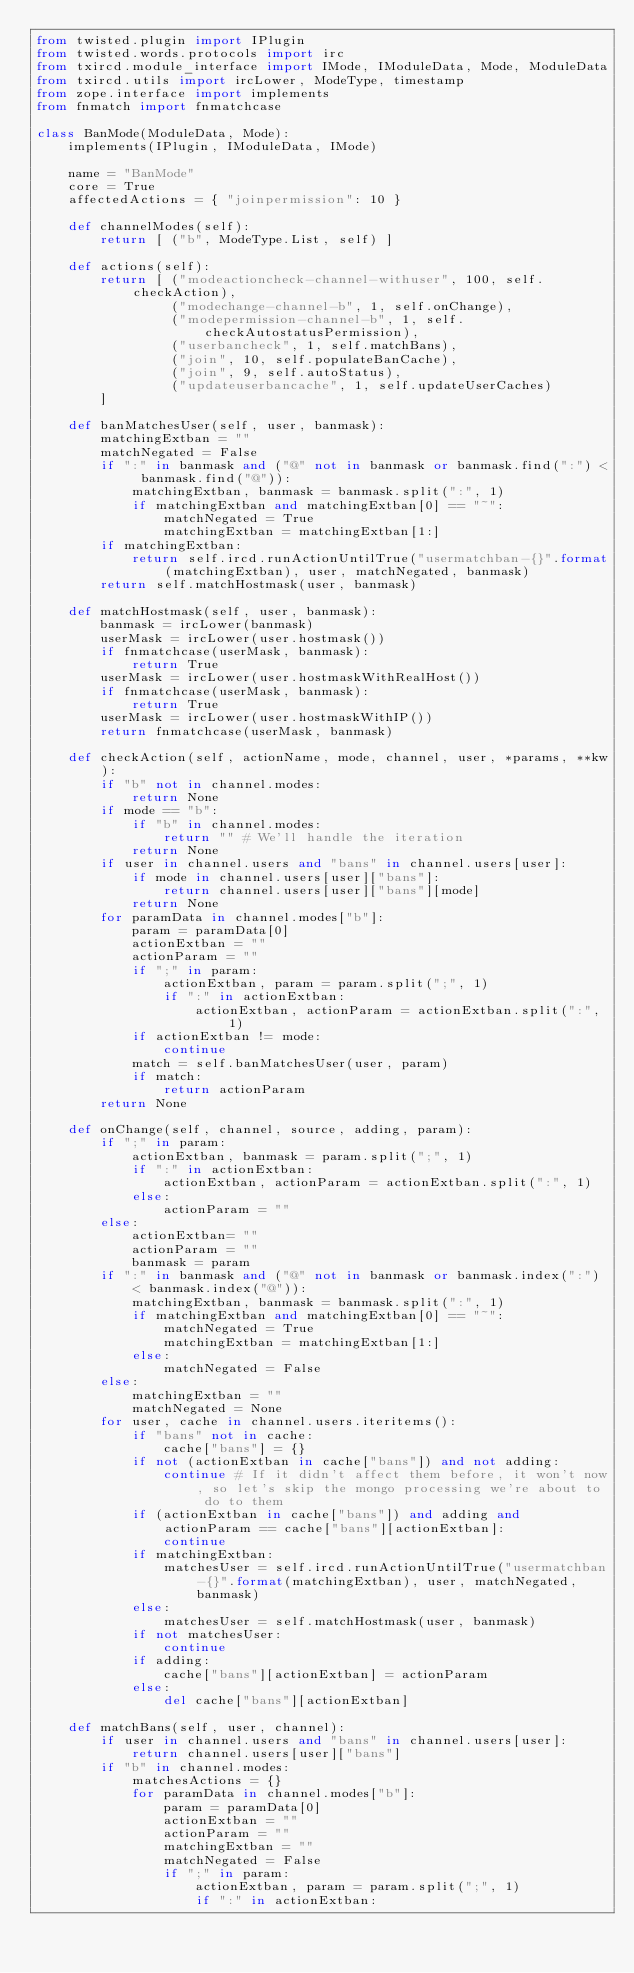Convert code to text. <code><loc_0><loc_0><loc_500><loc_500><_Python_>from twisted.plugin import IPlugin
from twisted.words.protocols import irc
from txircd.module_interface import IMode, IModuleData, Mode, ModuleData
from txircd.utils import ircLower, ModeType, timestamp
from zope.interface import implements
from fnmatch import fnmatchcase

class BanMode(ModuleData, Mode):
	implements(IPlugin, IModuleData, IMode)
	
	name = "BanMode"
	core = True
	affectedActions = { "joinpermission": 10 }
	
	def channelModes(self):
		return [ ("b", ModeType.List, self) ]
	
	def actions(self):
		return [ ("modeactioncheck-channel-withuser", 100, self.checkAction),
		         ("modechange-channel-b", 1, self.onChange),
		         ("modepermission-channel-b", 1, self.checkAutostatusPermission),
		         ("userbancheck", 1, self.matchBans),
		         ("join", 10, self.populateBanCache),
		         ("join", 9, self.autoStatus),
		         ("updateuserbancache", 1, self.updateUserCaches)
		]
	
	def banMatchesUser(self, user, banmask):
		matchingExtban = ""
		matchNegated = False
		if ":" in banmask and ("@" not in banmask or banmask.find(":") < banmask.find("@")):
			matchingExtban, banmask = banmask.split(":", 1)
			if matchingExtban and matchingExtban[0] == "~":
				matchNegated = True
				matchingExtban = matchingExtban[1:]
		if matchingExtban:
			return self.ircd.runActionUntilTrue("usermatchban-{}".format(matchingExtban), user, matchNegated, banmask)
		return self.matchHostmask(user, banmask)
	
	def matchHostmask(self, user, banmask):
		banmask = ircLower(banmask)
		userMask = ircLower(user.hostmask())
		if fnmatchcase(userMask, banmask):
			return True
		userMask = ircLower(user.hostmaskWithRealHost())
		if fnmatchcase(userMask, banmask):
			return True
		userMask = ircLower(user.hostmaskWithIP())
		return fnmatchcase(userMask, banmask)
	
	def checkAction(self, actionName, mode, channel, user, *params, **kw):
		if "b" not in channel.modes:
			return None
		if mode == "b":
			if "b" in channel.modes:
				return "" # We'll handle the iteration
			return None
		if user in channel.users and "bans" in channel.users[user]:
			if mode in channel.users[user]["bans"]:
				return channel.users[user]["bans"][mode]
			return None
		for paramData in channel.modes["b"]:
			param = paramData[0]
			actionExtban = ""
			actionParam = ""
			if ";" in param:
				actionExtban, param = param.split(";", 1)
				if ":" in actionExtban:
					actionExtban, actionParam = actionExtban.split(":", 1)
			if actionExtban != mode:
				continue
			match = self.banMatchesUser(user, param)
			if match:
				return actionParam
		return None
	
	def onChange(self, channel, source, adding, param):
		if ";" in param:
			actionExtban, banmask = param.split(";", 1)
			if ":" in actionExtban:
				actionExtban, actionParam = actionExtban.split(":", 1)
			else:
				actionParam = ""
		else:
			actionExtban= ""
			actionParam = ""
			banmask = param
		if ":" in banmask and ("@" not in banmask or banmask.index(":") < banmask.index("@")):
			matchingExtban, banmask = banmask.split(":", 1)
			if matchingExtban and matchingExtban[0] == "~":
				matchNegated = True
				matchingExtban = matchingExtban[1:]
			else:
				matchNegated = False
		else:
			matchingExtban = ""
			matchNegated = None
		for user, cache in channel.users.iteritems():
			if "bans" not in cache:
				cache["bans"] = {}
			if not (actionExtban in cache["bans"]) and not adding:
				continue # If it didn't affect them before, it won't now, so let's skip the mongo processing we're about to do to them
			if (actionExtban in cache["bans"]) and adding and actionParam == cache["bans"][actionExtban]:
				continue
			if matchingExtban:
				matchesUser = self.ircd.runActionUntilTrue("usermatchban-{}".format(matchingExtban), user, matchNegated, banmask)
			else:
				matchesUser = self.matchHostmask(user, banmask)
			if not matchesUser:
				continue
			if adding:
				cache["bans"][actionExtban] = actionParam
			else:
				del cache["bans"][actionExtban]
	
	def matchBans(self, user, channel):
		if user in channel.users and "bans" in channel.users[user]:
			return channel.users[user]["bans"]
		if "b" in channel.modes:
			matchesActions = {}
			for paramData in channel.modes["b"]:
				param = paramData[0]
				actionExtban = ""
				actionParam = ""
				matchingExtban = ""
				matchNegated = False
				if ";" in param:
					actionExtban, param = param.split(";", 1)
					if ":" in actionExtban:</code> 